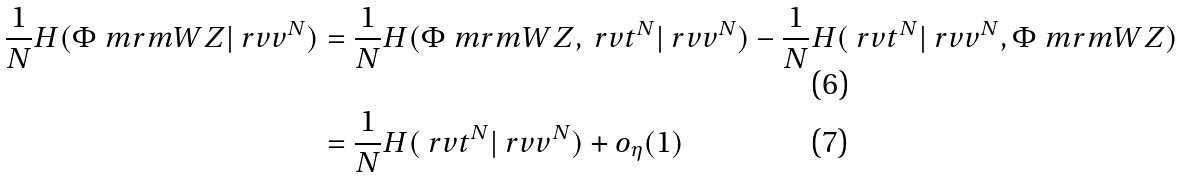Convert formula to latex. <formula><loc_0><loc_0><loc_500><loc_500>\frac { 1 } { N } H ( \Phi _ { \ } m r m { W Z } | \ r v v ^ { N } ) & = \frac { 1 } { N } H ( \Phi _ { \ } m r m { W Z } , \ r v t ^ { N } | \ r v v ^ { N } ) - \frac { 1 } { N } H ( \ r v t ^ { N } | \ r v v ^ { N } , \Phi _ { \ } m r m { W Z } ) \\ & = \frac { 1 } { N } H ( \ r v t ^ { N } | \ r v v ^ { N } ) + o _ { \eta } ( 1 )</formula> 